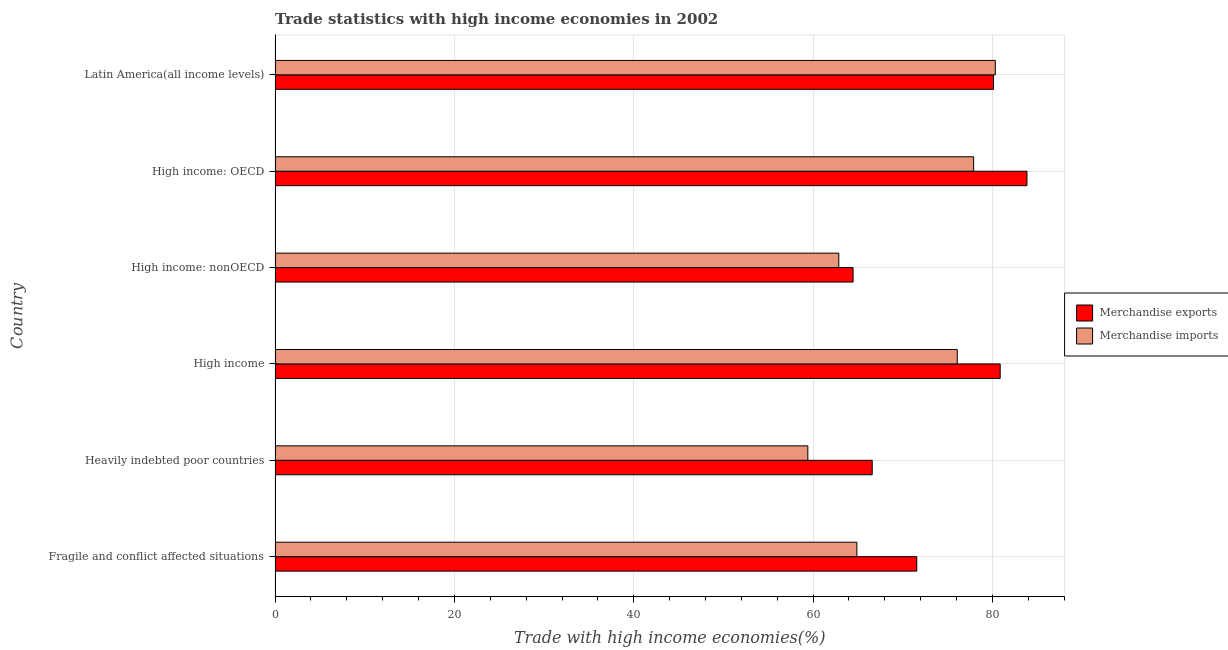How many different coloured bars are there?
Provide a succinct answer. 2. How many bars are there on the 3rd tick from the top?
Your response must be concise. 2. What is the label of the 3rd group of bars from the top?
Your answer should be compact. High income: nonOECD. In how many cases, is the number of bars for a given country not equal to the number of legend labels?
Your answer should be very brief. 0. What is the merchandise imports in High income?
Your answer should be very brief. 76.08. Across all countries, what is the maximum merchandise imports?
Ensure brevity in your answer.  80.33. Across all countries, what is the minimum merchandise imports?
Your answer should be very brief. 59.42. In which country was the merchandise imports maximum?
Ensure brevity in your answer.  Latin America(all income levels). In which country was the merchandise imports minimum?
Offer a very short reply. Heavily indebted poor countries. What is the total merchandise imports in the graph?
Offer a very short reply. 421.48. What is the difference between the merchandise imports in Heavily indebted poor countries and that in High income?
Offer a terse response. -16.66. What is the difference between the merchandise imports in Heavily indebted poor countries and the merchandise exports in High income: OECD?
Keep it short and to the point. -24.44. What is the average merchandise exports per country?
Your answer should be compact. 74.58. What is the difference between the merchandise exports and merchandise imports in High income: OECD?
Your answer should be very brief. 5.95. In how many countries, is the merchandise imports greater than 48 %?
Provide a short and direct response. 6. What is the difference between the highest and the second highest merchandise exports?
Offer a terse response. 2.99. What is the difference between the highest and the lowest merchandise imports?
Give a very brief answer. 20.91. Does the graph contain any zero values?
Offer a terse response. No. Does the graph contain grids?
Your answer should be compact. Yes. How are the legend labels stacked?
Provide a short and direct response. Vertical. What is the title of the graph?
Provide a succinct answer. Trade statistics with high income economies in 2002. What is the label or title of the X-axis?
Ensure brevity in your answer.  Trade with high income economies(%). What is the Trade with high income economies(%) in Merchandise exports in Fragile and conflict affected situations?
Make the answer very short. 71.56. What is the Trade with high income economies(%) of Merchandise imports in Fragile and conflict affected situations?
Make the answer very short. 64.89. What is the Trade with high income economies(%) in Merchandise exports in Heavily indebted poor countries?
Make the answer very short. 66.6. What is the Trade with high income economies(%) in Merchandise imports in Heavily indebted poor countries?
Offer a terse response. 59.42. What is the Trade with high income economies(%) of Merchandise exports in High income?
Offer a terse response. 80.87. What is the Trade with high income economies(%) in Merchandise imports in High income?
Offer a terse response. 76.08. What is the Trade with high income economies(%) of Merchandise exports in High income: nonOECD?
Offer a very short reply. 64.46. What is the Trade with high income economies(%) in Merchandise imports in High income: nonOECD?
Offer a very short reply. 62.87. What is the Trade with high income economies(%) in Merchandise exports in High income: OECD?
Keep it short and to the point. 83.86. What is the Trade with high income economies(%) of Merchandise imports in High income: OECD?
Your response must be concise. 77.91. What is the Trade with high income economies(%) in Merchandise exports in Latin America(all income levels)?
Make the answer very short. 80.12. What is the Trade with high income economies(%) of Merchandise imports in Latin America(all income levels)?
Your answer should be compact. 80.33. Across all countries, what is the maximum Trade with high income economies(%) in Merchandise exports?
Your response must be concise. 83.86. Across all countries, what is the maximum Trade with high income economies(%) in Merchandise imports?
Provide a short and direct response. 80.33. Across all countries, what is the minimum Trade with high income economies(%) of Merchandise exports?
Provide a succinct answer. 64.46. Across all countries, what is the minimum Trade with high income economies(%) of Merchandise imports?
Ensure brevity in your answer.  59.42. What is the total Trade with high income economies(%) in Merchandise exports in the graph?
Offer a terse response. 447.46. What is the total Trade with high income economies(%) of Merchandise imports in the graph?
Your answer should be compact. 421.48. What is the difference between the Trade with high income economies(%) in Merchandise exports in Fragile and conflict affected situations and that in Heavily indebted poor countries?
Provide a succinct answer. 4.97. What is the difference between the Trade with high income economies(%) of Merchandise imports in Fragile and conflict affected situations and that in Heavily indebted poor countries?
Make the answer very short. 5.47. What is the difference between the Trade with high income economies(%) of Merchandise exports in Fragile and conflict affected situations and that in High income?
Your response must be concise. -9.3. What is the difference between the Trade with high income economies(%) in Merchandise imports in Fragile and conflict affected situations and that in High income?
Your response must be concise. -11.2. What is the difference between the Trade with high income economies(%) in Merchandise exports in Fragile and conflict affected situations and that in High income: nonOECD?
Make the answer very short. 7.1. What is the difference between the Trade with high income economies(%) of Merchandise imports in Fragile and conflict affected situations and that in High income: nonOECD?
Your answer should be very brief. 2.02. What is the difference between the Trade with high income economies(%) of Merchandise exports in Fragile and conflict affected situations and that in High income: OECD?
Offer a terse response. -12.29. What is the difference between the Trade with high income economies(%) of Merchandise imports in Fragile and conflict affected situations and that in High income: OECD?
Make the answer very short. -13.02. What is the difference between the Trade with high income economies(%) in Merchandise exports in Fragile and conflict affected situations and that in Latin America(all income levels)?
Provide a short and direct response. -8.55. What is the difference between the Trade with high income economies(%) of Merchandise imports in Fragile and conflict affected situations and that in Latin America(all income levels)?
Keep it short and to the point. -15.44. What is the difference between the Trade with high income economies(%) of Merchandise exports in Heavily indebted poor countries and that in High income?
Offer a terse response. -14.27. What is the difference between the Trade with high income economies(%) in Merchandise imports in Heavily indebted poor countries and that in High income?
Give a very brief answer. -16.66. What is the difference between the Trade with high income economies(%) of Merchandise exports in Heavily indebted poor countries and that in High income: nonOECD?
Make the answer very short. 2.13. What is the difference between the Trade with high income economies(%) in Merchandise imports in Heavily indebted poor countries and that in High income: nonOECD?
Your answer should be very brief. -3.45. What is the difference between the Trade with high income economies(%) of Merchandise exports in Heavily indebted poor countries and that in High income: OECD?
Offer a very short reply. -17.26. What is the difference between the Trade with high income economies(%) in Merchandise imports in Heavily indebted poor countries and that in High income: OECD?
Give a very brief answer. -18.49. What is the difference between the Trade with high income economies(%) of Merchandise exports in Heavily indebted poor countries and that in Latin America(all income levels)?
Provide a short and direct response. -13.52. What is the difference between the Trade with high income economies(%) in Merchandise imports in Heavily indebted poor countries and that in Latin America(all income levels)?
Provide a short and direct response. -20.91. What is the difference between the Trade with high income economies(%) of Merchandise exports in High income and that in High income: nonOECD?
Provide a succinct answer. 16.41. What is the difference between the Trade with high income economies(%) of Merchandise imports in High income and that in High income: nonOECD?
Make the answer very short. 13.21. What is the difference between the Trade with high income economies(%) of Merchandise exports in High income and that in High income: OECD?
Provide a succinct answer. -2.99. What is the difference between the Trade with high income economies(%) in Merchandise imports in High income and that in High income: OECD?
Offer a very short reply. -1.83. What is the difference between the Trade with high income economies(%) of Merchandise exports in High income and that in Latin America(all income levels)?
Keep it short and to the point. 0.75. What is the difference between the Trade with high income economies(%) of Merchandise imports in High income and that in Latin America(all income levels)?
Keep it short and to the point. -4.25. What is the difference between the Trade with high income economies(%) in Merchandise exports in High income: nonOECD and that in High income: OECD?
Keep it short and to the point. -19.39. What is the difference between the Trade with high income economies(%) in Merchandise imports in High income: nonOECD and that in High income: OECD?
Your response must be concise. -15.04. What is the difference between the Trade with high income economies(%) in Merchandise exports in High income: nonOECD and that in Latin America(all income levels)?
Provide a succinct answer. -15.66. What is the difference between the Trade with high income economies(%) of Merchandise imports in High income: nonOECD and that in Latin America(all income levels)?
Keep it short and to the point. -17.46. What is the difference between the Trade with high income economies(%) in Merchandise exports in High income: OECD and that in Latin America(all income levels)?
Provide a short and direct response. 3.74. What is the difference between the Trade with high income economies(%) of Merchandise imports in High income: OECD and that in Latin America(all income levels)?
Your response must be concise. -2.42. What is the difference between the Trade with high income economies(%) in Merchandise exports in Fragile and conflict affected situations and the Trade with high income economies(%) in Merchandise imports in Heavily indebted poor countries?
Give a very brief answer. 12.15. What is the difference between the Trade with high income economies(%) of Merchandise exports in Fragile and conflict affected situations and the Trade with high income economies(%) of Merchandise imports in High income?
Your response must be concise. -4.52. What is the difference between the Trade with high income economies(%) in Merchandise exports in Fragile and conflict affected situations and the Trade with high income economies(%) in Merchandise imports in High income: nonOECD?
Your answer should be very brief. 8.7. What is the difference between the Trade with high income economies(%) in Merchandise exports in Fragile and conflict affected situations and the Trade with high income economies(%) in Merchandise imports in High income: OECD?
Make the answer very short. -6.34. What is the difference between the Trade with high income economies(%) of Merchandise exports in Fragile and conflict affected situations and the Trade with high income economies(%) of Merchandise imports in Latin America(all income levels)?
Offer a very short reply. -8.76. What is the difference between the Trade with high income economies(%) of Merchandise exports in Heavily indebted poor countries and the Trade with high income economies(%) of Merchandise imports in High income?
Give a very brief answer. -9.49. What is the difference between the Trade with high income economies(%) of Merchandise exports in Heavily indebted poor countries and the Trade with high income economies(%) of Merchandise imports in High income: nonOECD?
Offer a very short reply. 3.73. What is the difference between the Trade with high income economies(%) in Merchandise exports in Heavily indebted poor countries and the Trade with high income economies(%) in Merchandise imports in High income: OECD?
Your answer should be very brief. -11.31. What is the difference between the Trade with high income economies(%) in Merchandise exports in Heavily indebted poor countries and the Trade with high income economies(%) in Merchandise imports in Latin America(all income levels)?
Your response must be concise. -13.73. What is the difference between the Trade with high income economies(%) in Merchandise exports in High income and the Trade with high income economies(%) in Merchandise imports in High income: OECD?
Provide a succinct answer. 2.96. What is the difference between the Trade with high income economies(%) in Merchandise exports in High income and the Trade with high income economies(%) in Merchandise imports in Latin America(all income levels)?
Offer a terse response. 0.54. What is the difference between the Trade with high income economies(%) of Merchandise exports in High income: nonOECD and the Trade with high income economies(%) of Merchandise imports in High income: OECD?
Your response must be concise. -13.44. What is the difference between the Trade with high income economies(%) in Merchandise exports in High income: nonOECD and the Trade with high income economies(%) in Merchandise imports in Latin America(all income levels)?
Offer a very short reply. -15.86. What is the difference between the Trade with high income economies(%) in Merchandise exports in High income: OECD and the Trade with high income economies(%) in Merchandise imports in Latin America(all income levels)?
Your answer should be very brief. 3.53. What is the average Trade with high income economies(%) in Merchandise exports per country?
Give a very brief answer. 74.58. What is the average Trade with high income economies(%) of Merchandise imports per country?
Provide a succinct answer. 70.25. What is the difference between the Trade with high income economies(%) of Merchandise exports and Trade with high income economies(%) of Merchandise imports in Fragile and conflict affected situations?
Ensure brevity in your answer.  6.68. What is the difference between the Trade with high income economies(%) of Merchandise exports and Trade with high income economies(%) of Merchandise imports in Heavily indebted poor countries?
Make the answer very short. 7.18. What is the difference between the Trade with high income economies(%) of Merchandise exports and Trade with high income economies(%) of Merchandise imports in High income?
Offer a very short reply. 4.79. What is the difference between the Trade with high income economies(%) in Merchandise exports and Trade with high income economies(%) in Merchandise imports in High income: nonOECD?
Your answer should be compact. 1.59. What is the difference between the Trade with high income economies(%) in Merchandise exports and Trade with high income economies(%) in Merchandise imports in High income: OECD?
Your answer should be compact. 5.95. What is the difference between the Trade with high income economies(%) of Merchandise exports and Trade with high income economies(%) of Merchandise imports in Latin America(all income levels)?
Make the answer very short. -0.21. What is the ratio of the Trade with high income economies(%) of Merchandise exports in Fragile and conflict affected situations to that in Heavily indebted poor countries?
Your answer should be compact. 1.07. What is the ratio of the Trade with high income economies(%) in Merchandise imports in Fragile and conflict affected situations to that in Heavily indebted poor countries?
Keep it short and to the point. 1.09. What is the ratio of the Trade with high income economies(%) in Merchandise exports in Fragile and conflict affected situations to that in High income?
Your response must be concise. 0.89. What is the ratio of the Trade with high income economies(%) in Merchandise imports in Fragile and conflict affected situations to that in High income?
Give a very brief answer. 0.85. What is the ratio of the Trade with high income economies(%) in Merchandise exports in Fragile and conflict affected situations to that in High income: nonOECD?
Your answer should be very brief. 1.11. What is the ratio of the Trade with high income economies(%) of Merchandise imports in Fragile and conflict affected situations to that in High income: nonOECD?
Provide a short and direct response. 1.03. What is the ratio of the Trade with high income economies(%) of Merchandise exports in Fragile and conflict affected situations to that in High income: OECD?
Your answer should be compact. 0.85. What is the ratio of the Trade with high income economies(%) of Merchandise imports in Fragile and conflict affected situations to that in High income: OECD?
Ensure brevity in your answer.  0.83. What is the ratio of the Trade with high income economies(%) of Merchandise exports in Fragile and conflict affected situations to that in Latin America(all income levels)?
Offer a terse response. 0.89. What is the ratio of the Trade with high income economies(%) in Merchandise imports in Fragile and conflict affected situations to that in Latin America(all income levels)?
Offer a terse response. 0.81. What is the ratio of the Trade with high income economies(%) of Merchandise exports in Heavily indebted poor countries to that in High income?
Offer a terse response. 0.82. What is the ratio of the Trade with high income economies(%) of Merchandise imports in Heavily indebted poor countries to that in High income?
Give a very brief answer. 0.78. What is the ratio of the Trade with high income economies(%) of Merchandise exports in Heavily indebted poor countries to that in High income: nonOECD?
Keep it short and to the point. 1.03. What is the ratio of the Trade with high income economies(%) of Merchandise imports in Heavily indebted poor countries to that in High income: nonOECD?
Give a very brief answer. 0.95. What is the ratio of the Trade with high income economies(%) in Merchandise exports in Heavily indebted poor countries to that in High income: OECD?
Provide a short and direct response. 0.79. What is the ratio of the Trade with high income economies(%) of Merchandise imports in Heavily indebted poor countries to that in High income: OECD?
Keep it short and to the point. 0.76. What is the ratio of the Trade with high income economies(%) of Merchandise exports in Heavily indebted poor countries to that in Latin America(all income levels)?
Offer a terse response. 0.83. What is the ratio of the Trade with high income economies(%) in Merchandise imports in Heavily indebted poor countries to that in Latin America(all income levels)?
Give a very brief answer. 0.74. What is the ratio of the Trade with high income economies(%) in Merchandise exports in High income to that in High income: nonOECD?
Offer a terse response. 1.25. What is the ratio of the Trade with high income economies(%) of Merchandise imports in High income to that in High income: nonOECD?
Ensure brevity in your answer.  1.21. What is the ratio of the Trade with high income economies(%) of Merchandise exports in High income to that in High income: OECD?
Provide a succinct answer. 0.96. What is the ratio of the Trade with high income economies(%) of Merchandise imports in High income to that in High income: OECD?
Your answer should be very brief. 0.98. What is the ratio of the Trade with high income economies(%) of Merchandise exports in High income to that in Latin America(all income levels)?
Your response must be concise. 1.01. What is the ratio of the Trade with high income economies(%) in Merchandise imports in High income to that in Latin America(all income levels)?
Give a very brief answer. 0.95. What is the ratio of the Trade with high income economies(%) in Merchandise exports in High income: nonOECD to that in High income: OECD?
Offer a terse response. 0.77. What is the ratio of the Trade with high income economies(%) of Merchandise imports in High income: nonOECD to that in High income: OECD?
Offer a terse response. 0.81. What is the ratio of the Trade with high income economies(%) of Merchandise exports in High income: nonOECD to that in Latin America(all income levels)?
Give a very brief answer. 0.8. What is the ratio of the Trade with high income economies(%) in Merchandise imports in High income: nonOECD to that in Latin America(all income levels)?
Make the answer very short. 0.78. What is the ratio of the Trade with high income economies(%) in Merchandise exports in High income: OECD to that in Latin America(all income levels)?
Provide a succinct answer. 1.05. What is the ratio of the Trade with high income economies(%) in Merchandise imports in High income: OECD to that in Latin America(all income levels)?
Your answer should be compact. 0.97. What is the difference between the highest and the second highest Trade with high income economies(%) of Merchandise exports?
Offer a very short reply. 2.99. What is the difference between the highest and the second highest Trade with high income economies(%) of Merchandise imports?
Ensure brevity in your answer.  2.42. What is the difference between the highest and the lowest Trade with high income economies(%) of Merchandise exports?
Keep it short and to the point. 19.39. What is the difference between the highest and the lowest Trade with high income economies(%) in Merchandise imports?
Provide a short and direct response. 20.91. 